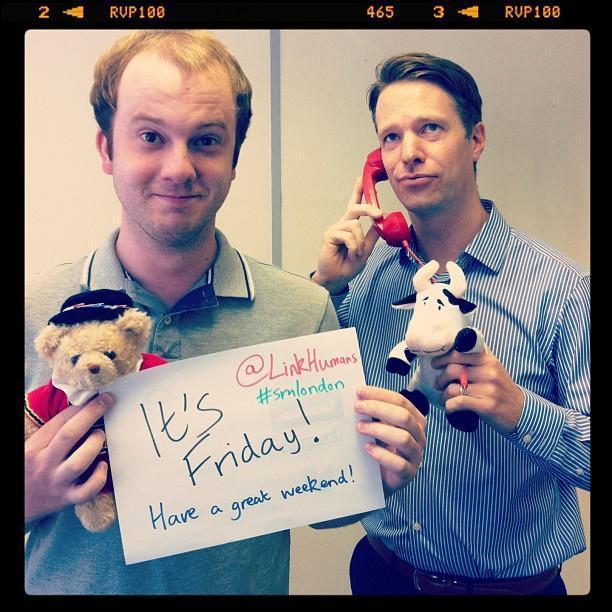How many people are there?
Give a very brief answer. 2. 